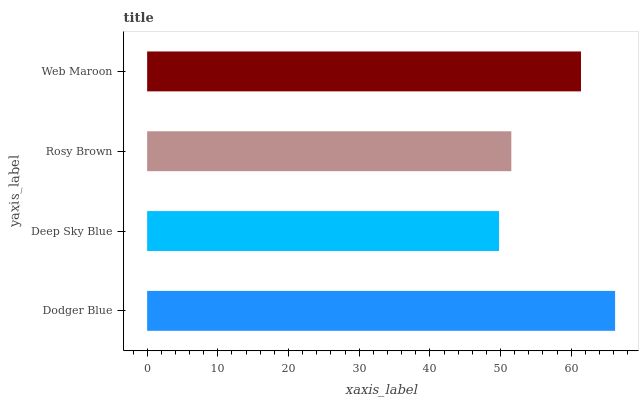Is Deep Sky Blue the minimum?
Answer yes or no. Yes. Is Dodger Blue the maximum?
Answer yes or no. Yes. Is Rosy Brown the minimum?
Answer yes or no. No. Is Rosy Brown the maximum?
Answer yes or no. No. Is Rosy Brown greater than Deep Sky Blue?
Answer yes or no. Yes. Is Deep Sky Blue less than Rosy Brown?
Answer yes or no. Yes. Is Deep Sky Blue greater than Rosy Brown?
Answer yes or no. No. Is Rosy Brown less than Deep Sky Blue?
Answer yes or no. No. Is Web Maroon the high median?
Answer yes or no. Yes. Is Rosy Brown the low median?
Answer yes or no. Yes. Is Deep Sky Blue the high median?
Answer yes or no. No. Is Dodger Blue the low median?
Answer yes or no. No. 